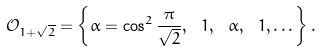Convert formula to latex. <formula><loc_0><loc_0><loc_500><loc_500>\mathcal { O } _ { 1 + \sqrt { 2 } } = \left \{ \alpha = \cos ^ { 2 } \frac { \pi } { \sqrt { 2 } } , \ 1 , \ \alpha , \ 1 , \dots \right \} .</formula> 